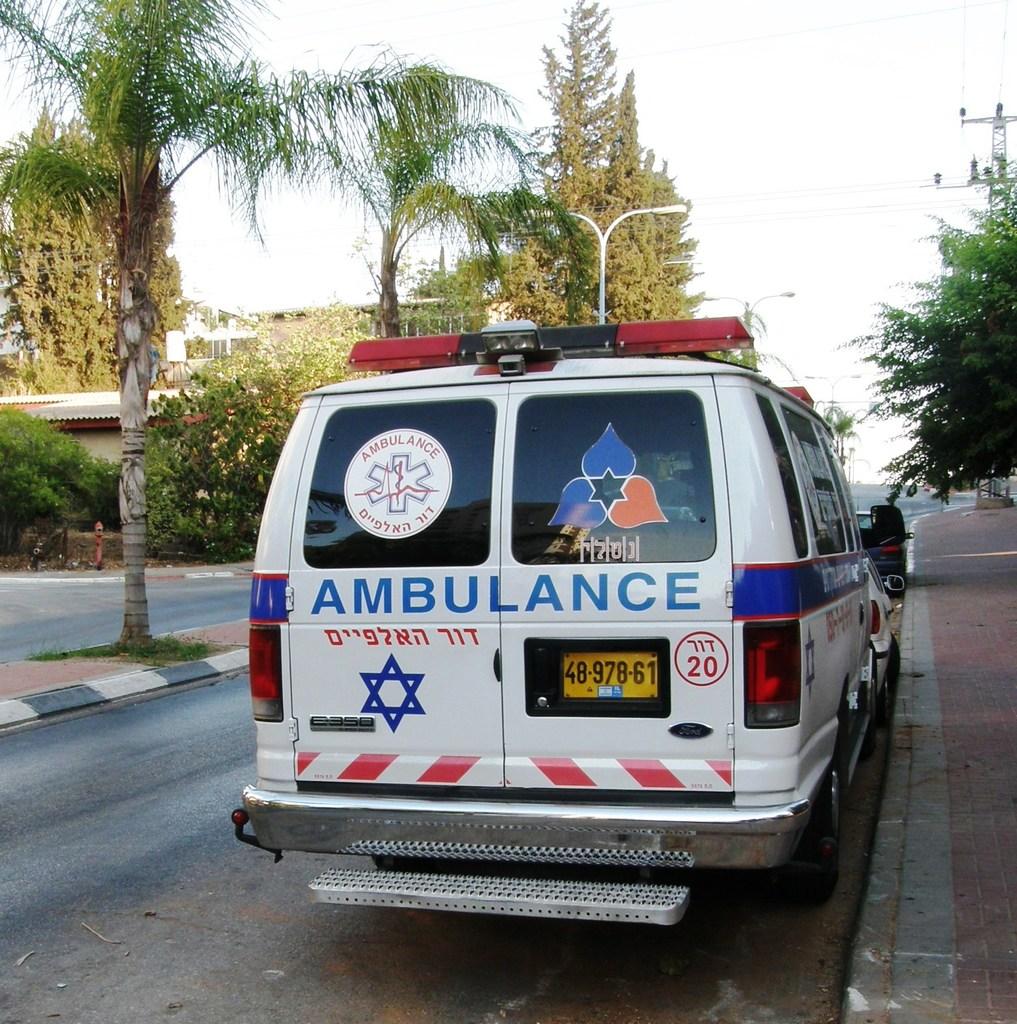What kind of service vehicle is this?
Offer a very short reply. Ambulance. 